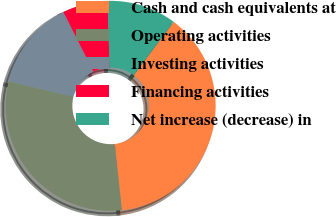<chart> <loc_0><loc_0><loc_500><loc_500><pie_chart><fcel>Cash and cash equivalents at<fcel>Operating activities<fcel>Investing activities<fcel>Financing activities<fcel>Net increase (decrease) in<nl><fcel>38.06%<fcel>30.47%<fcel>13.81%<fcel>6.96%<fcel>10.7%<nl></chart> 